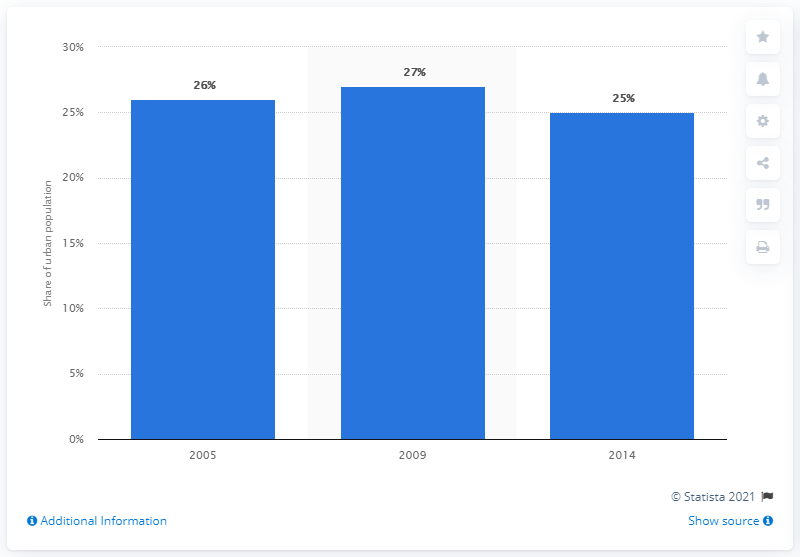Identify some key points in this picture. In 2009, the population was 1% higher than in 2005. In 2009, approximately 27% of Thailand's urban population lived in slums. The average population is 26. 